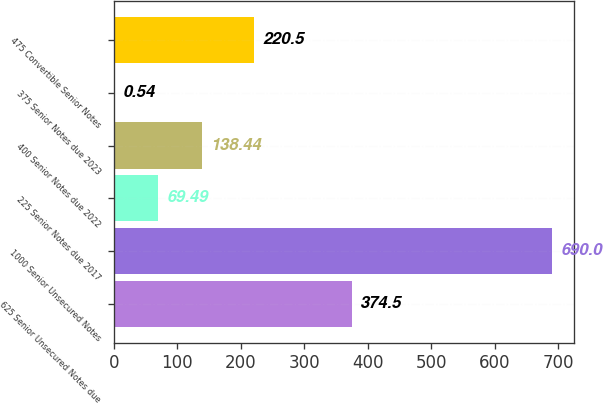Convert chart to OTSL. <chart><loc_0><loc_0><loc_500><loc_500><bar_chart><fcel>625 Senior Unsecured Notes due<fcel>1000 Senior Unsecured Notes<fcel>225 Senior Notes due 2017<fcel>400 Senior Notes due 2022<fcel>375 Senior Notes due 2023<fcel>475 Convertible Senior Notes<nl><fcel>374.5<fcel>690<fcel>69.49<fcel>138.44<fcel>0.54<fcel>220.5<nl></chart> 